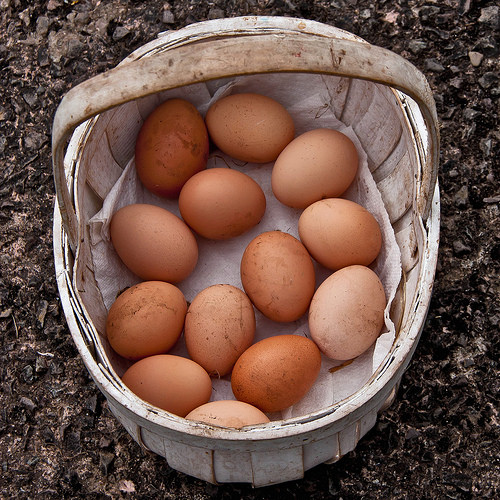<image>
Can you confirm if the egg is on the basket? Yes. Looking at the image, I can see the egg is positioned on top of the basket, with the basket providing support. 